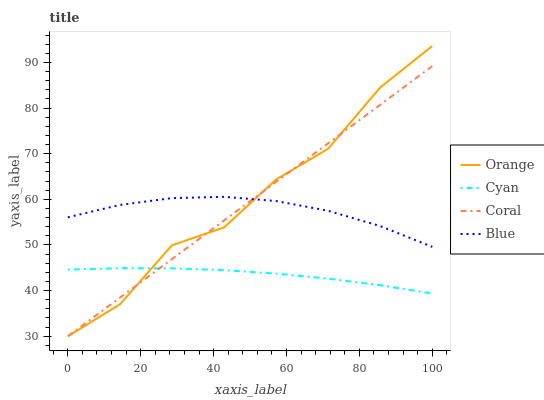Does Coral have the minimum area under the curve?
Answer yes or no. No. Does Coral have the maximum area under the curve?
Answer yes or no. No. Is Cyan the smoothest?
Answer yes or no. No. Is Cyan the roughest?
Answer yes or no. No. Does Cyan have the lowest value?
Answer yes or no. No. Does Coral have the highest value?
Answer yes or no. No. Is Cyan less than Blue?
Answer yes or no. Yes. Is Blue greater than Cyan?
Answer yes or no. Yes. Does Cyan intersect Blue?
Answer yes or no. No. 